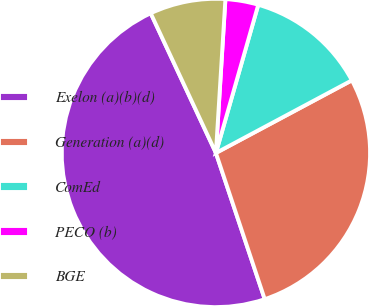Convert chart to OTSL. <chart><loc_0><loc_0><loc_500><loc_500><pie_chart><fcel>Exelon (a)(b)(d)<fcel>Generation (a)(d)<fcel>ComEd<fcel>PECO (b)<fcel>BGE<nl><fcel>48.18%<fcel>27.68%<fcel>12.76%<fcel>3.45%<fcel>7.93%<nl></chart> 